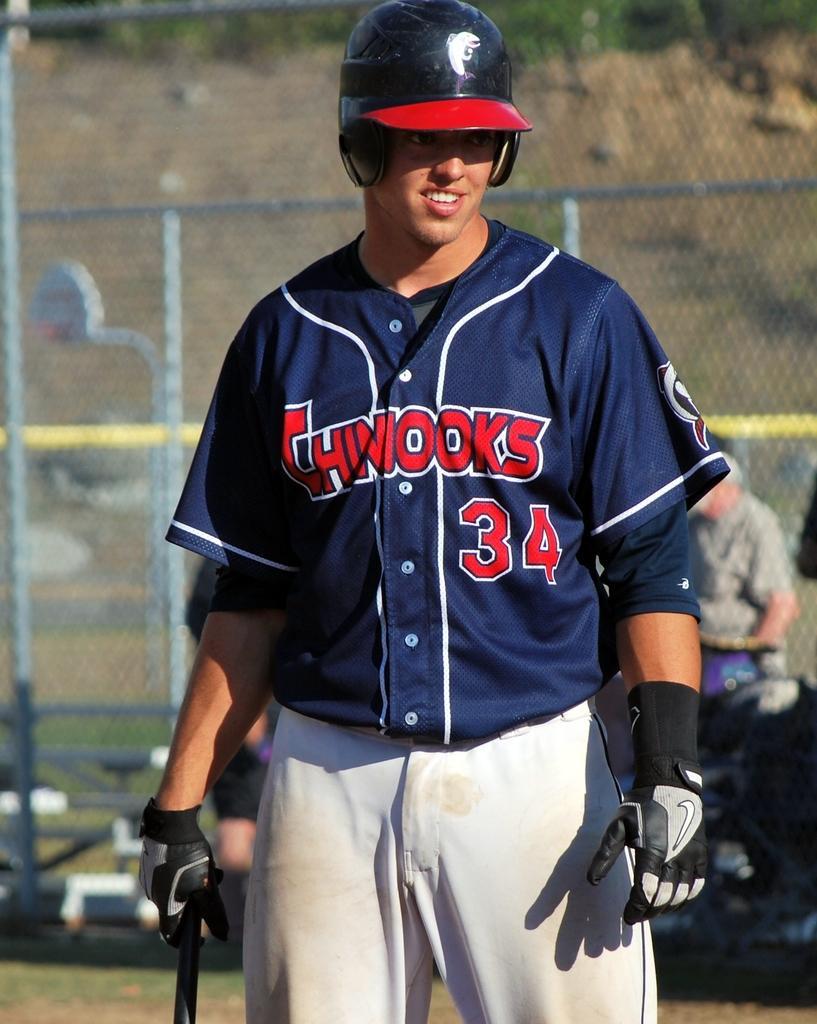Can you describe this image briefly? In the middle of the image a man is standing and holding a baseball bat. Behind him there is a fencing and few people are standing and sitting. Behind the fencing there is a hill. 